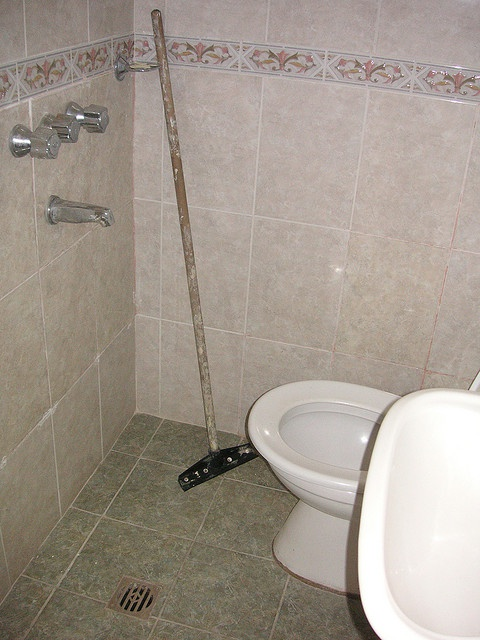Describe the objects in this image and their specific colors. I can see sink in gray, white, lightgray, tan, and darkgray tones and toilet in gray, darkgray, and lightgray tones in this image. 